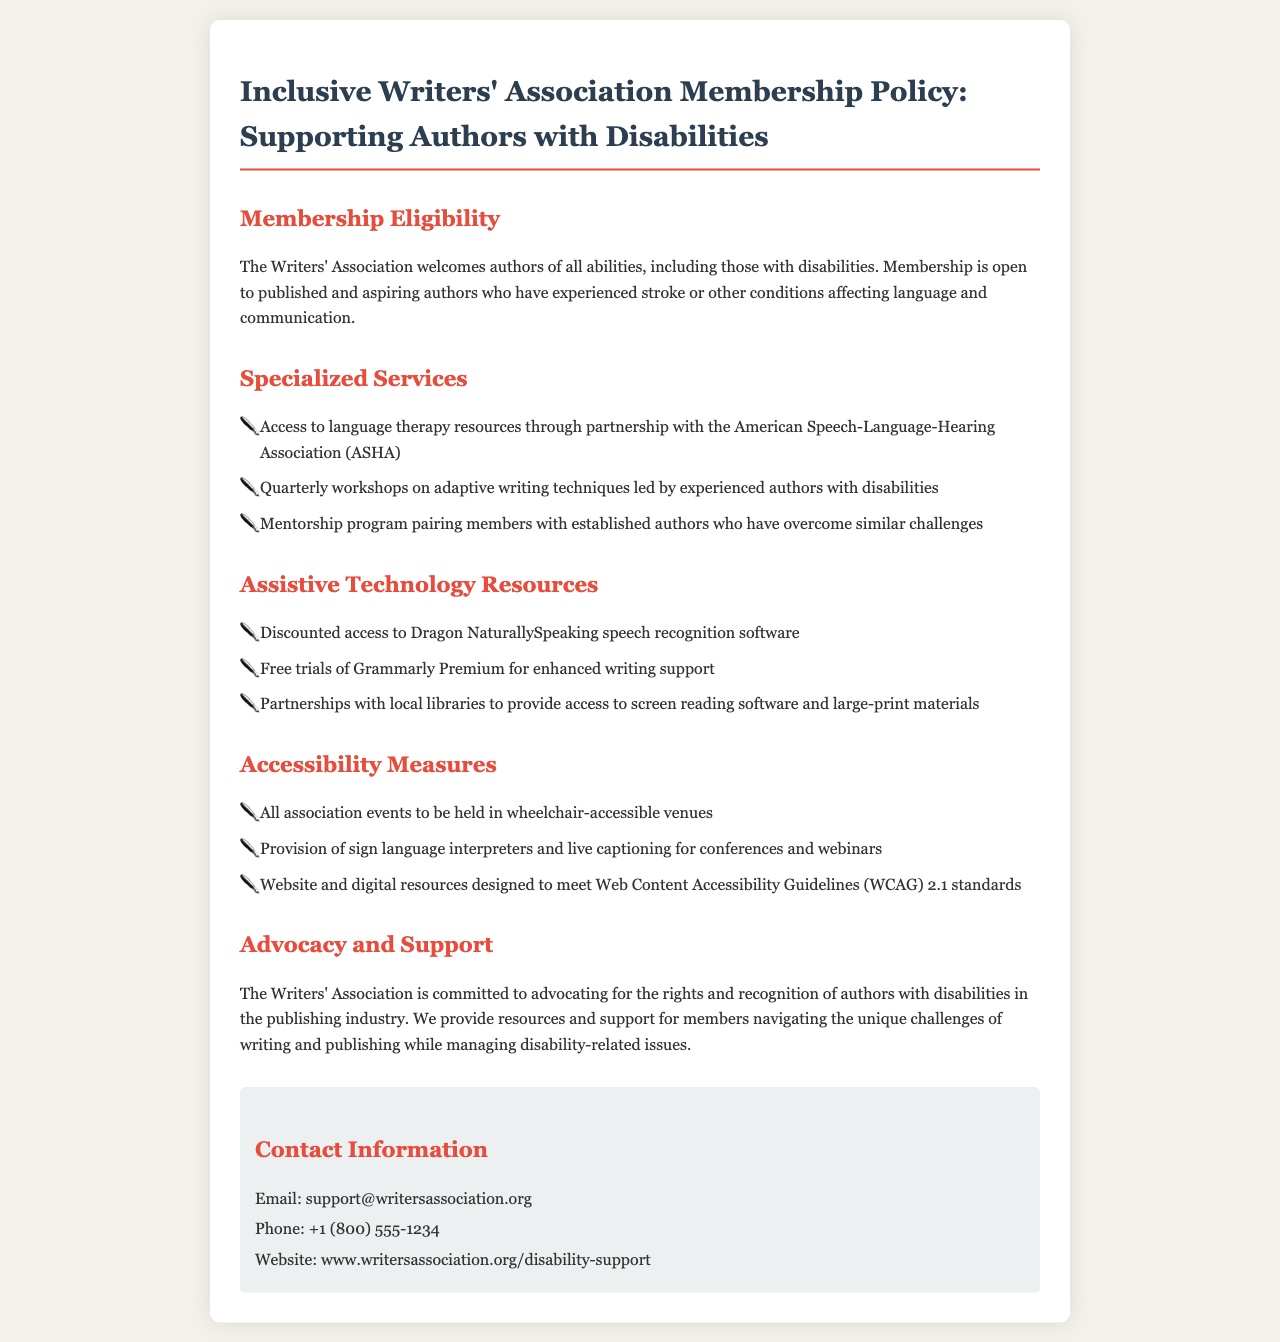What is the main focus of the membership policy? The main focus is to support authors with disabilities.
Answer: Supporting authors with disabilities Who is eligible for membership? Membership is open to published and aspiring authors who have experienced stroke or other conditions affecting language and communication.
Answer: Authors with disabilities What partnership provides language therapy resources? The partnership is with the American Speech-Language-Hearing Association (ASHA).
Answer: ASHA What software is offered at a discounted rate? The software offered at a discounted rate is Dragon NaturallySpeaking.
Answer: Dragon NaturallySpeaking How often are workshops on adaptive writing techniques held? Workshops on adaptive writing techniques are held quarterly.
Answer: Quarterly What measures are taken to ensure accessibility at events? All association events are held in wheelchair-accessible venues.
Answer: Wheelchair-accessible venues What advocacy role does the Writers' Association undertake? The association advocates for the rights and recognition of authors with disabilities.
Answer: Advocacy for rights Which communication support is provided during conferences? Sign language interpreters and live captioning are provided.
Answer: Sign language interpreters and live captioning What is the contact email for support? The contact email for support is support@writersassociation.org.
Answer: support@writersassociation.org 